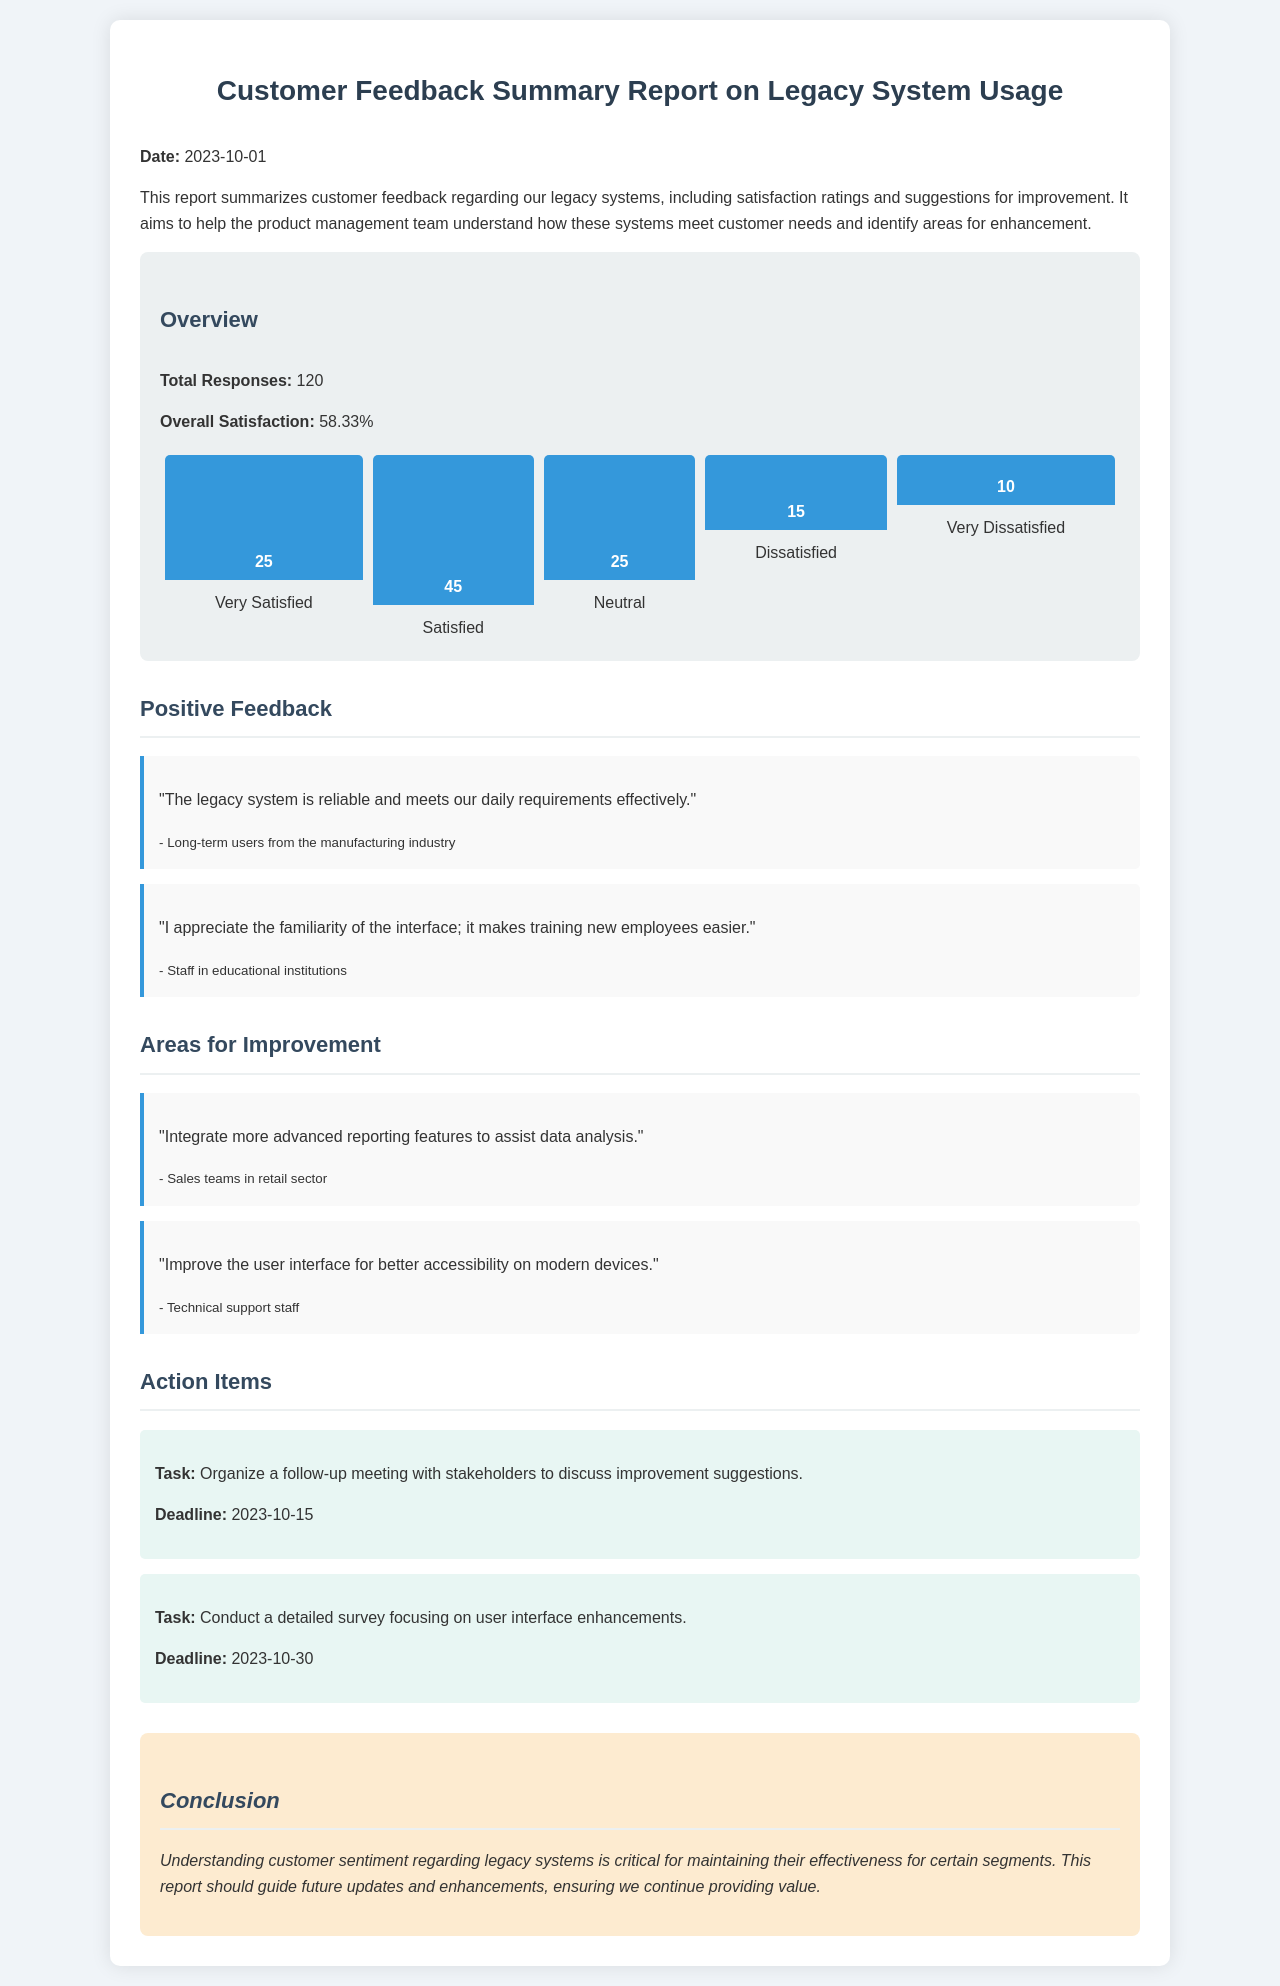What is the date of the report? The date of the report is stated clearly at the beginning of the document.
Answer: 2023-10-01 What is the total number of responses? The total responses are mentioned in the overview section of the report.
Answer: 120 What is the overall satisfaction percentage? The overall satisfaction percentage is provided in the overview section, which summarizes customer sentiment.
Answer: 58.33% How many customers reported being very satisfied? The number of customers who reported being very satisfied is shown in the satisfaction chart.
Answer: 25 Which sector appreciated the familiarity of the interface? The feedback mentioning familiarity of the interface attributes it to staff in a specific sector.
Answer: Educational institutions What improvement do sales teams in the retail sector suggest? Sales teams in the retail sector provided a specific suggestion regarding features in their feedback.
Answer: Advanced reporting features What is the deadline for organizing a follow-up meeting? The document provides a deadline for the follow-up meeting in the action items section.
Answer: 2023-10-15 What can be inferred about customer sentiment toward legacy systems? The conclusion draws an inference about why understanding customer sentiment is important for legacy systems.
Answer: Critical What task involves conducting a detailed survey? The task related to surveying is specified in the action items section.
Answer: User interface enhancements 